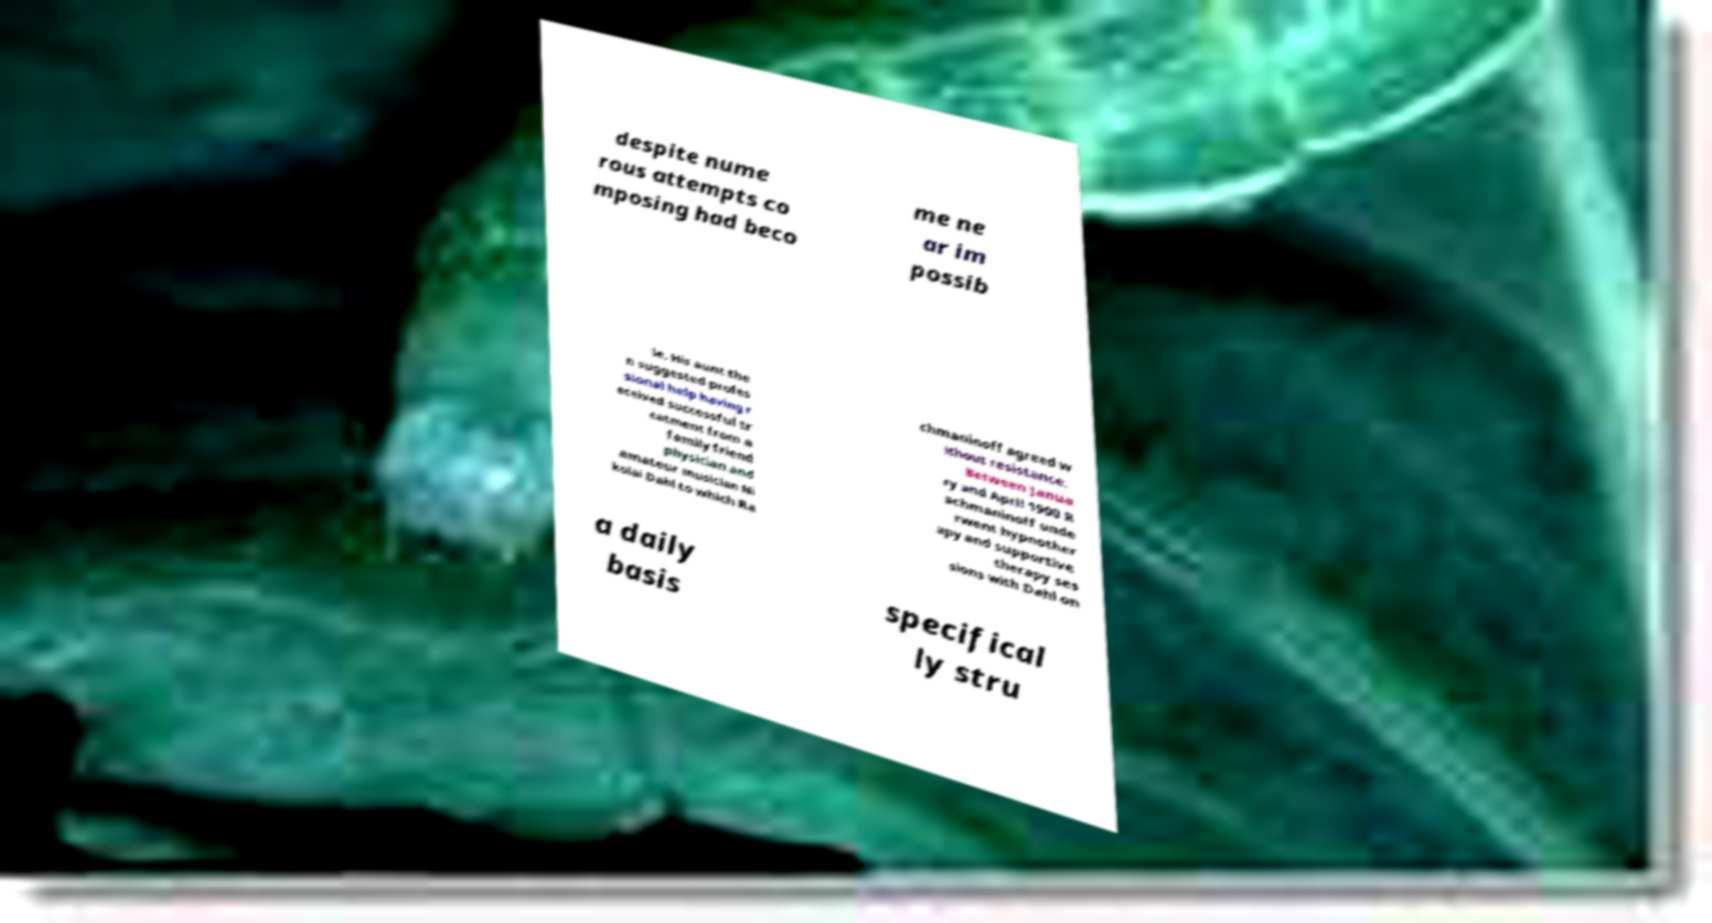Please identify and transcribe the text found in this image. despite nume rous attempts co mposing had beco me ne ar im possib le. His aunt the n suggested profes sional help having r eceived successful tr eatment from a family friend physician and amateur musician Ni kolai Dahl to which Ra chmaninoff agreed w ithout resistance. Between Janua ry and April 1900 R achmaninoff unde rwent hypnother apy and supportive therapy ses sions with Dahl on a daily basis specifical ly stru 